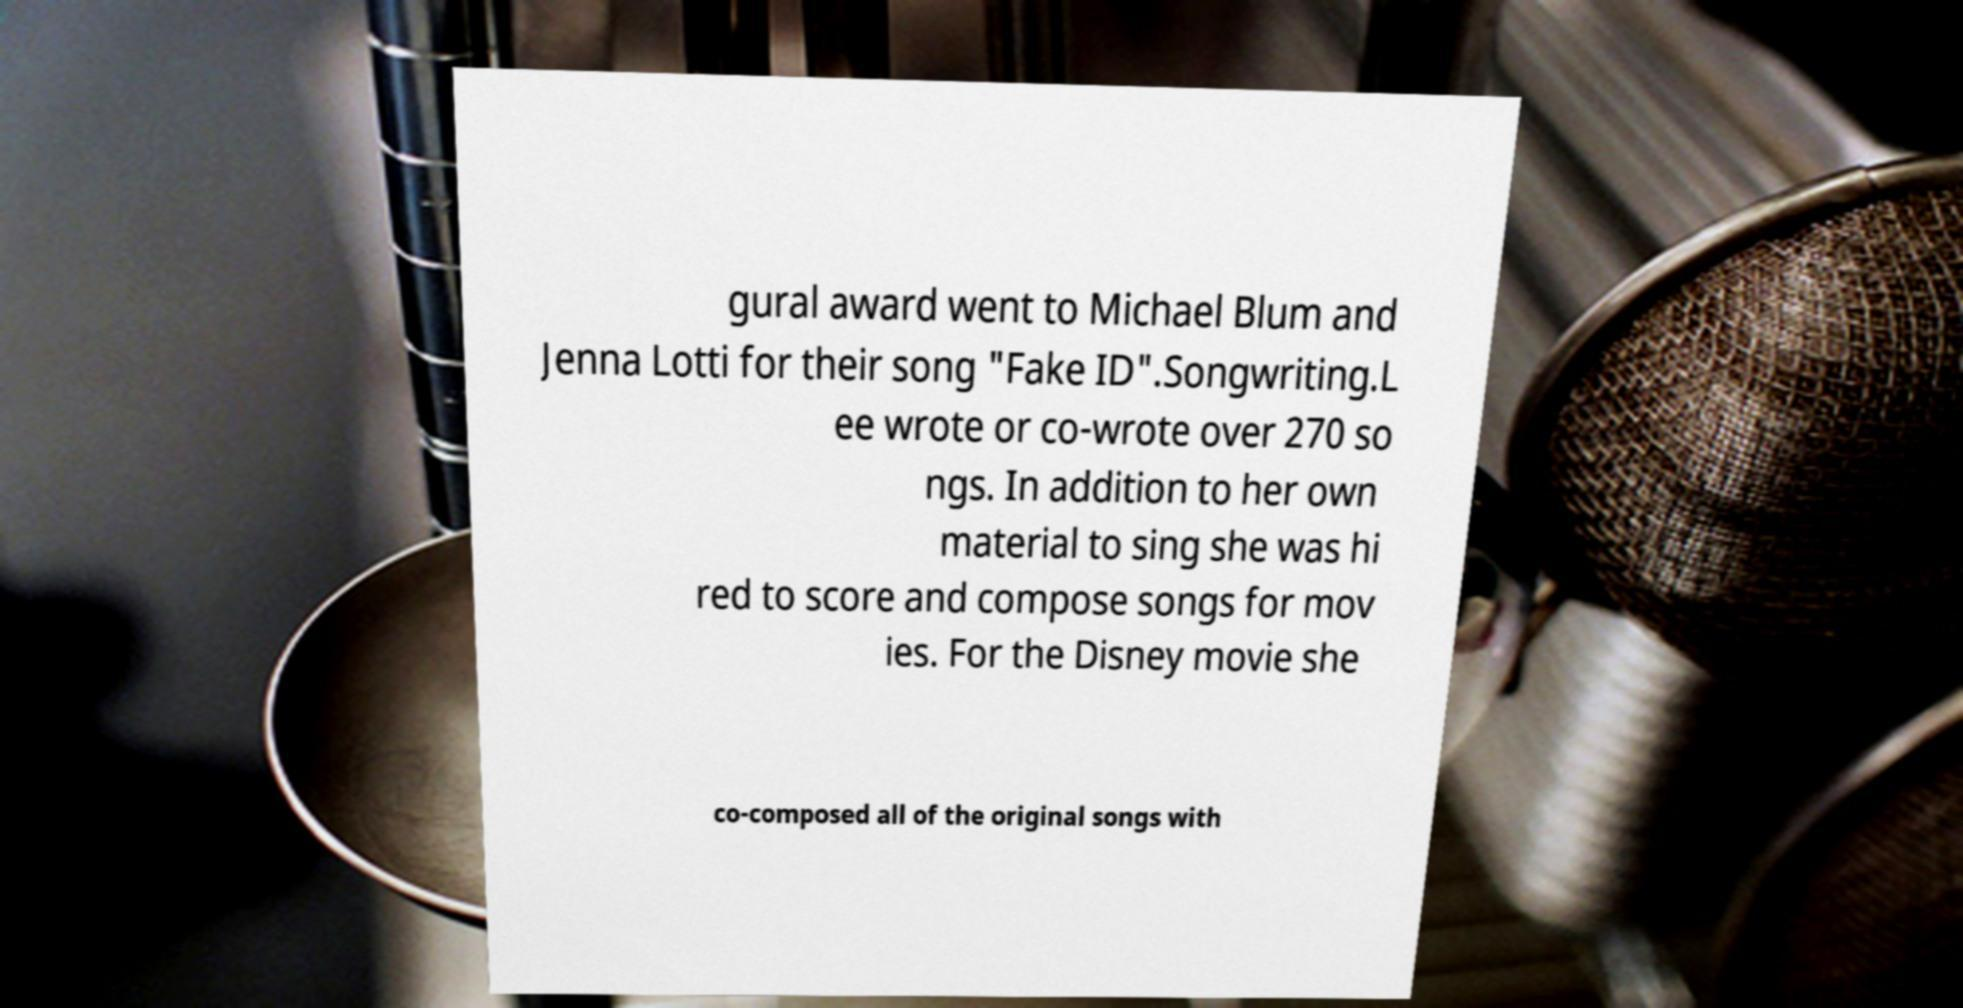There's text embedded in this image that I need extracted. Can you transcribe it verbatim? gural award went to Michael Blum and Jenna Lotti for their song "Fake ID".Songwriting.L ee wrote or co-wrote over 270 so ngs. In addition to her own material to sing she was hi red to score and compose songs for mov ies. For the Disney movie she co-composed all of the original songs with 